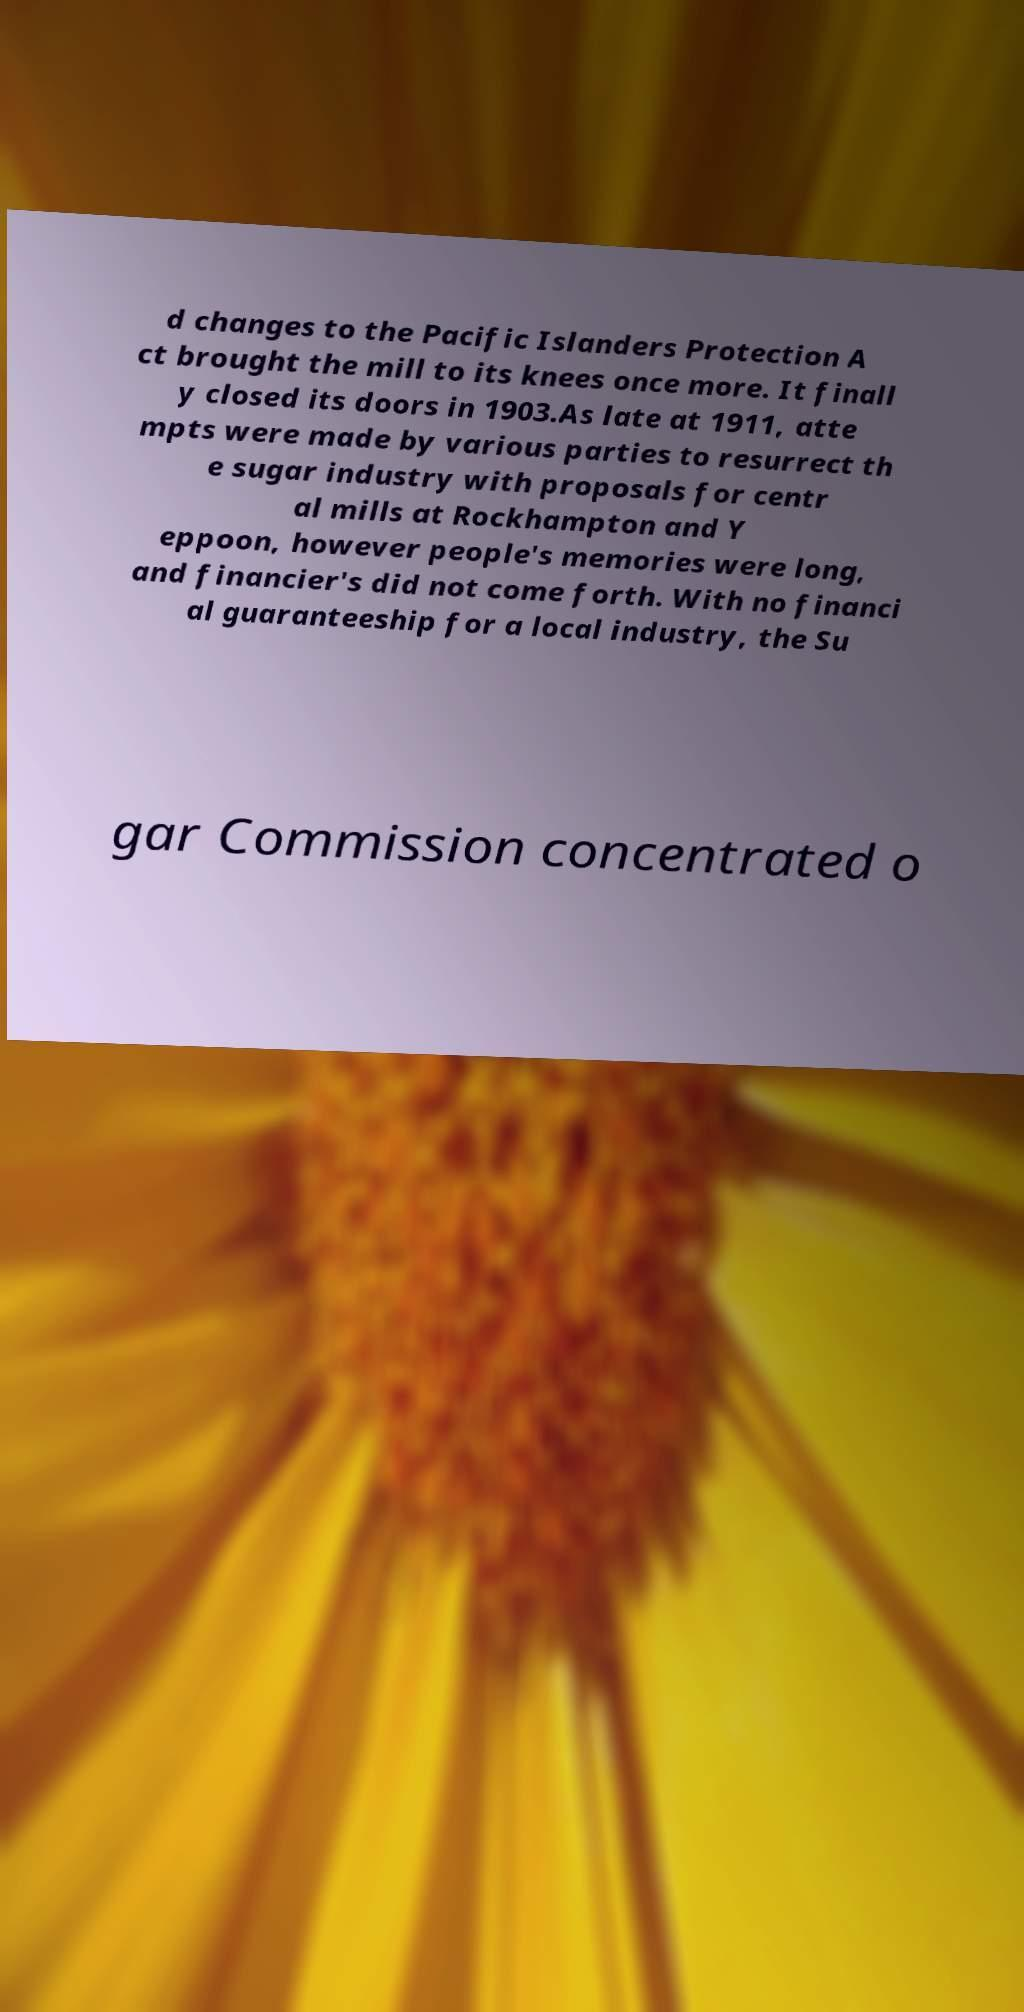Could you assist in decoding the text presented in this image and type it out clearly? d changes to the Pacific Islanders Protection A ct brought the mill to its knees once more. It finall y closed its doors in 1903.As late at 1911, atte mpts were made by various parties to resurrect th e sugar industry with proposals for centr al mills at Rockhampton and Y eppoon, however people's memories were long, and financier's did not come forth. With no financi al guaranteeship for a local industry, the Su gar Commission concentrated o 